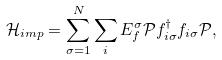<formula> <loc_0><loc_0><loc_500><loc_500>\mathcal { H } _ { i m p } = \sum _ { \sigma = 1 } ^ { N } \sum _ { i } E _ { f } ^ { \sigma } \mathcal { P } f ^ { \dagger } _ { i \sigma } f _ { i \sigma } \mathcal { P } ,</formula> 